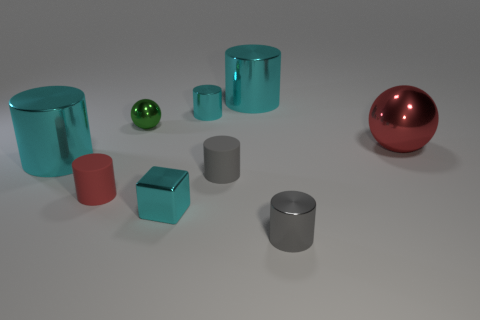Subtract all cyan cylinders. How many were subtracted if there are1cyan cylinders left? 2 Subtract all big cylinders. How many cylinders are left? 4 Subtract 1 cylinders. How many cylinders are left? 5 Subtract all red cylinders. How many cylinders are left? 5 Add 4 tiny red rubber cylinders. How many tiny red rubber cylinders are left? 5 Add 2 tiny things. How many tiny things exist? 8 Subtract 0 cyan balls. How many objects are left? 9 Subtract all cylinders. How many objects are left? 3 Subtract all gray spheres. Subtract all blue cylinders. How many spheres are left? 2 Subtract all yellow cubes. How many green balls are left? 1 